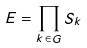Convert formula to latex. <formula><loc_0><loc_0><loc_500><loc_500>E = \prod _ { k \in G } S _ { k }</formula> 